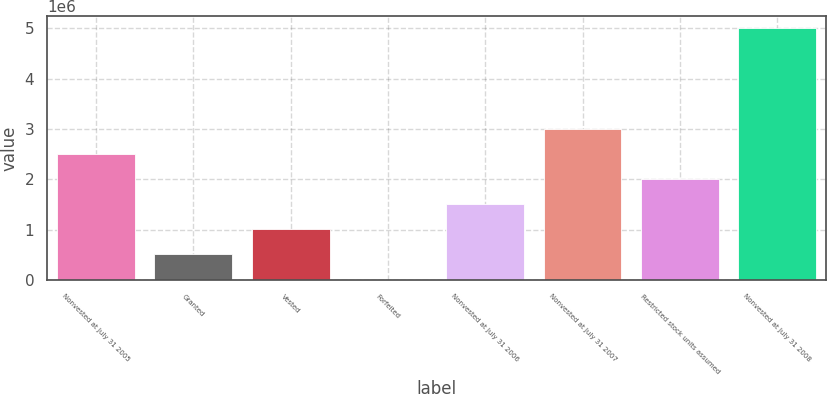Convert chart to OTSL. <chart><loc_0><loc_0><loc_500><loc_500><bar_chart><fcel>Nonvested at July 31 2005<fcel>Granted<fcel>Vested<fcel>Forfeited<fcel>Nonvested at July 31 2006<fcel>Nonvested at July 31 2007<fcel>Restricted stock units assumed<fcel>Nonvested at July 31 2008<nl><fcel>2.50077e+06<fcel>503517<fcel>1.00283e+06<fcel>4204<fcel>1.50214e+06<fcel>3.00008e+06<fcel>2.00146e+06<fcel>4.99733e+06<nl></chart> 